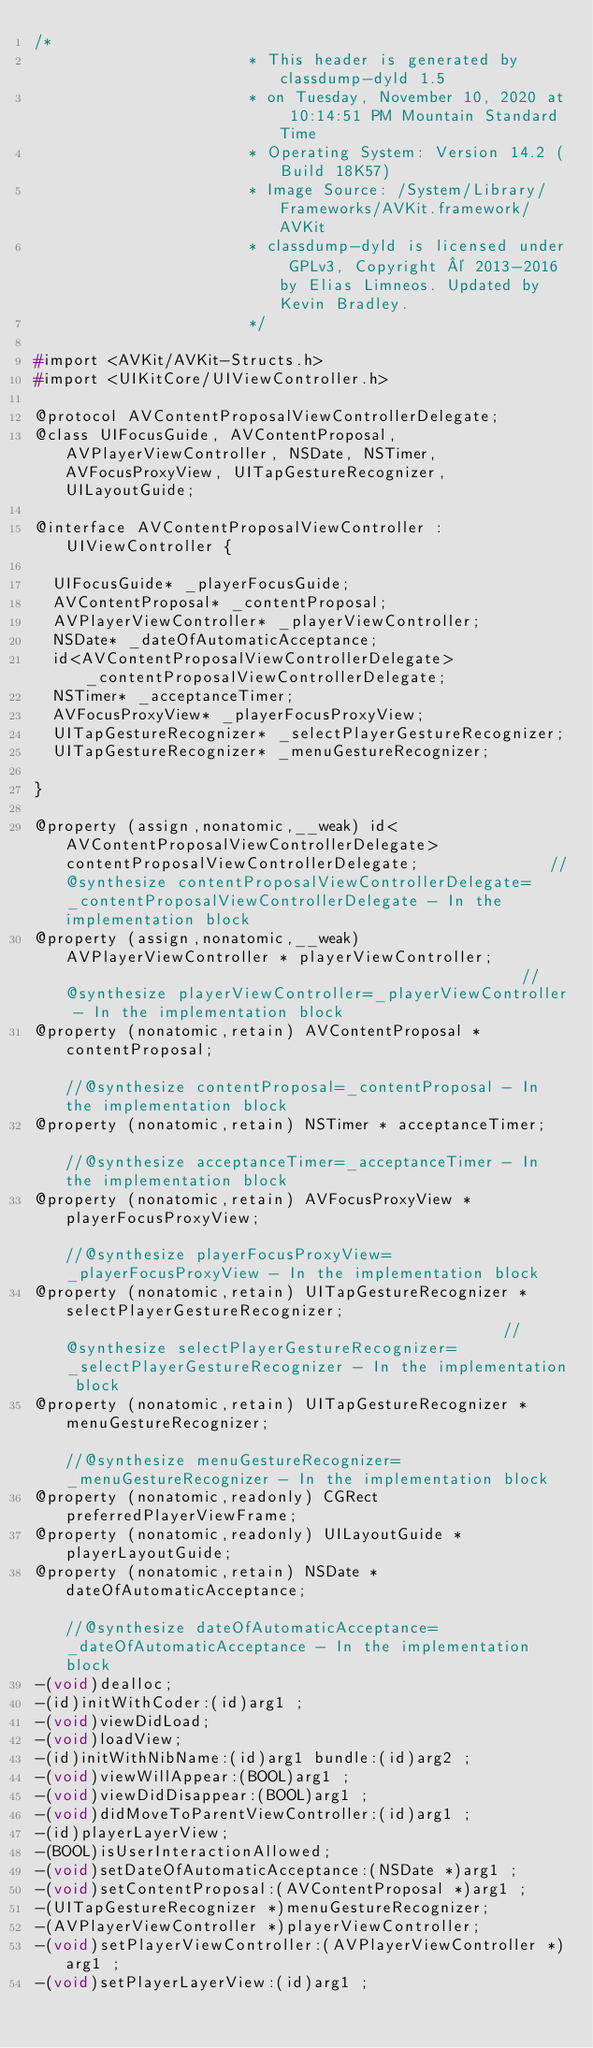<code> <loc_0><loc_0><loc_500><loc_500><_C_>/*
                       * This header is generated by classdump-dyld 1.5
                       * on Tuesday, November 10, 2020 at 10:14:51 PM Mountain Standard Time
                       * Operating System: Version 14.2 (Build 18K57)
                       * Image Source: /System/Library/Frameworks/AVKit.framework/AVKit
                       * classdump-dyld is licensed under GPLv3, Copyright © 2013-2016 by Elias Limneos. Updated by Kevin Bradley.
                       */

#import <AVKit/AVKit-Structs.h>
#import <UIKitCore/UIViewController.h>

@protocol AVContentProposalViewControllerDelegate;
@class UIFocusGuide, AVContentProposal, AVPlayerViewController, NSDate, NSTimer, AVFocusProxyView, UITapGestureRecognizer, UILayoutGuide;

@interface AVContentProposalViewController : UIViewController {

	UIFocusGuide* _playerFocusGuide;
	AVContentProposal* _contentProposal;
	AVPlayerViewController* _playerViewController;
	NSDate* _dateOfAutomaticAcceptance;
	id<AVContentProposalViewControllerDelegate> _contentProposalViewControllerDelegate;
	NSTimer* _acceptanceTimer;
	AVFocusProxyView* _playerFocusProxyView;
	UITapGestureRecognizer* _selectPlayerGestureRecognizer;
	UITapGestureRecognizer* _menuGestureRecognizer;

}

@property (assign,nonatomic,__weak) id<AVContentProposalViewControllerDelegate> contentProposalViewControllerDelegate;              //@synthesize contentProposalViewControllerDelegate=_contentProposalViewControllerDelegate - In the implementation block
@property (assign,nonatomic,__weak) AVPlayerViewController * playerViewController;                                                  //@synthesize playerViewController=_playerViewController - In the implementation block
@property (nonatomic,retain) AVContentProposal * contentProposal;                                                                   //@synthesize contentProposal=_contentProposal - In the implementation block
@property (nonatomic,retain) NSTimer * acceptanceTimer;                                                                             //@synthesize acceptanceTimer=_acceptanceTimer - In the implementation block
@property (nonatomic,retain) AVFocusProxyView * playerFocusProxyView;                                                               //@synthesize playerFocusProxyView=_playerFocusProxyView - In the implementation block
@property (nonatomic,retain) UITapGestureRecognizer * selectPlayerGestureRecognizer;                                                //@synthesize selectPlayerGestureRecognizer=_selectPlayerGestureRecognizer - In the implementation block
@property (nonatomic,retain) UITapGestureRecognizer * menuGestureRecognizer;                                                        //@synthesize menuGestureRecognizer=_menuGestureRecognizer - In the implementation block
@property (nonatomic,readonly) CGRect preferredPlayerViewFrame; 
@property (nonatomic,readonly) UILayoutGuide * playerLayoutGuide; 
@property (nonatomic,retain) NSDate * dateOfAutomaticAcceptance;                                                                    //@synthesize dateOfAutomaticAcceptance=_dateOfAutomaticAcceptance - In the implementation block
-(void)dealloc;
-(id)initWithCoder:(id)arg1 ;
-(void)viewDidLoad;
-(void)loadView;
-(id)initWithNibName:(id)arg1 bundle:(id)arg2 ;
-(void)viewWillAppear:(BOOL)arg1 ;
-(void)viewDidDisappear:(BOOL)arg1 ;
-(void)didMoveToParentViewController:(id)arg1 ;
-(id)playerLayerView;
-(BOOL)isUserInteractionAllowed;
-(void)setDateOfAutomaticAcceptance:(NSDate *)arg1 ;
-(void)setContentProposal:(AVContentProposal *)arg1 ;
-(UITapGestureRecognizer *)menuGestureRecognizer;
-(AVPlayerViewController *)playerViewController;
-(void)setPlayerViewController:(AVPlayerViewController *)arg1 ;
-(void)setPlayerLayerView:(id)arg1 ;</code> 